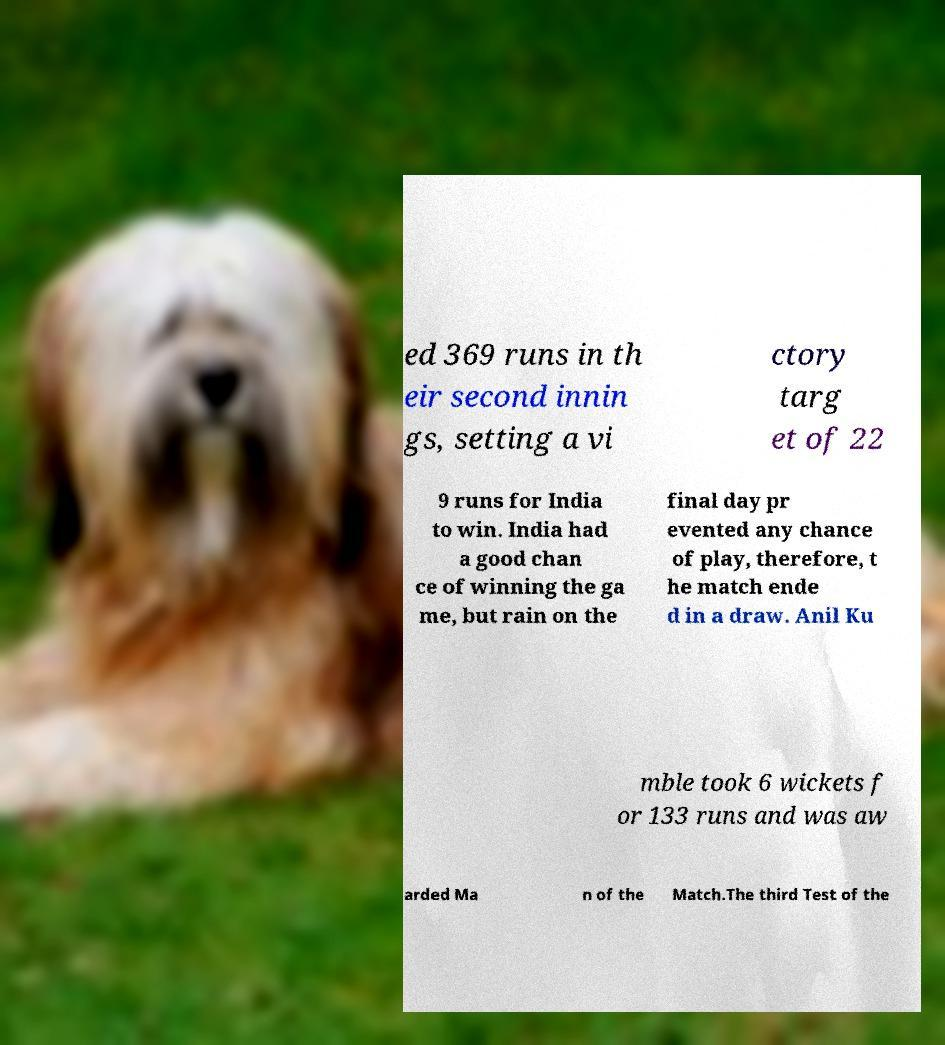I need the written content from this picture converted into text. Can you do that? ed 369 runs in th eir second innin gs, setting a vi ctory targ et of 22 9 runs for India to win. India had a good chan ce of winning the ga me, but rain on the final day pr evented any chance of play, therefore, t he match ende d in a draw. Anil Ku mble took 6 wickets f or 133 runs and was aw arded Ma n of the Match.The third Test of the 